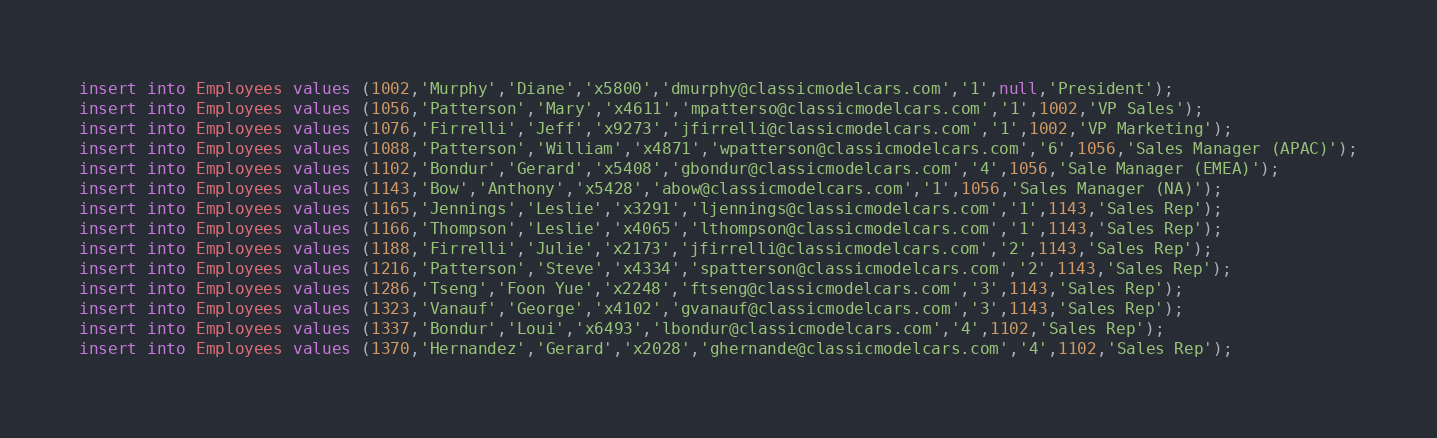<code> <loc_0><loc_0><loc_500><loc_500><_SQL_>insert into Employees values (1002,'Murphy','Diane','x5800','dmurphy@classicmodelcars.com','1',null,'President');
insert into Employees values (1056,'Patterson','Mary','x4611','mpatterso@classicmodelcars.com','1',1002,'VP Sales');
insert into Employees values (1076,'Firrelli','Jeff','x9273','jfirrelli@classicmodelcars.com','1',1002,'VP Marketing');
insert into Employees values (1088,'Patterson','William','x4871','wpatterson@classicmodelcars.com','6',1056,'Sales Manager (APAC)');
insert into Employees values (1102,'Bondur','Gerard','x5408','gbondur@classicmodelcars.com','4',1056,'Sale Manager (EMEA)');
insert into Employees values (1143,'Bow','Anthony','x5428','abow@classicmodelcars.com','1',1056,'Sales Manager (NA)');
insert into Employees values (1165,'Jennings','Leslie','x3291','ljennings@classicmodelcars.com','1',1143,'Sales Rep');
insert into Employees values (1166,'Thompson','Leslie','x4065','lthompson@classicmodelcars.com','1',1143,'Sales Rep');
insert into Employees values (1188,'Firrelli','Julie','x2173','jfirrelli@classicmodelcars.com','2',1143,'Sales Rep');
insert into Employees values (1216,'Patterson','Steve','x4334','spatterson@classicmodelcars.com','2',1143,'Sales Rep');
insert into Employees values (1286,'Tseng','Foon Yue','x2248','ftseng@classicmodelcars.com','3',1143,'Sales Rep');
insert into Employees values (1323,'Vanauf','George','x4102','gvanauf@classicmodelcars.com','3',1143,'Sales Rep');
insert into Employees values (1337,'Bondur','Loui','x6493','lbondur@classicmodelcars.com','4',1102,'Sales Rep');
insert into Employees values (1370,'Hernandez','Gerard','x2028','ghernande@classicmodelcars.com','4',1102,'Sales Rep');</code> 